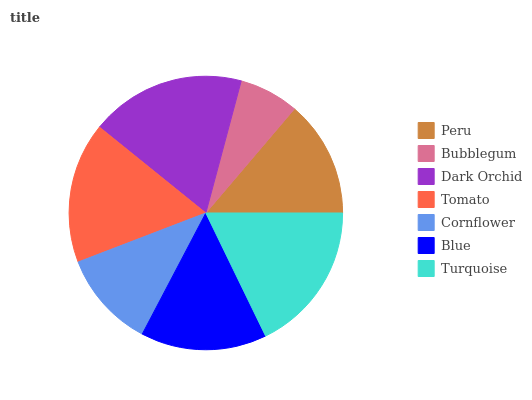Is Bubblegum the minimum?
Answer yes or no. Yes. Is Dark Orchid the maximum?
Answer yes or no. Yes. Is Dark Orchid the minimum?
Answer yes or no. No. Is Bubblegum the maximum?
Answer yes or no. No. Is Dark Orchid greater than Bubblegum?
Answer yes or no. Yes. Is Bubblegum less than Dark Orchid?
Answer yes or no. Yes. Is Bubblegum greater than Dark Orchid?
Answer yes or no. No. Is Dark Orchid less than Bubblegum?
Answer yes or no. No. Is Blue the high median?
Answer yes or no. Yes. Is Blue the low median?
Answer yes or no. Yes. Is Bubblegum the high median?
Answer yes or no. No. Is Tomato the low median?
Answer yes or no. No. 